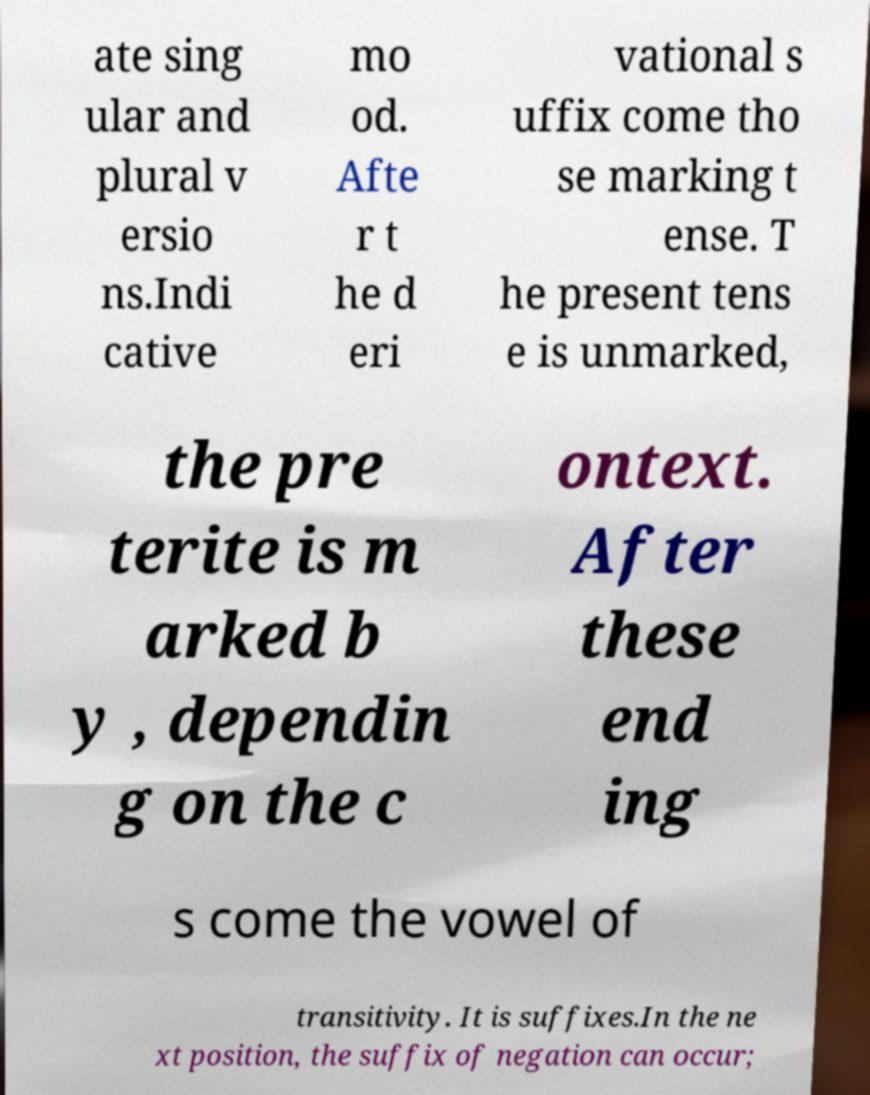Please identify and transcribe the text found in this image. ate sing ular and plural v ersio ns.Indi cative mo od. Afte r t he d eri vational s uffix come tho se marking t ense. T he present tens e is unmarked, the pre terite is m arked b y , dependin g on the c ontext. After these end ing s come the vowel of transitivity. It is suffixes.In the ne xt position, the suffix of negation can occur; 